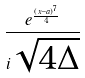Convert formula to latex. <formula><loc_0><loc_0><loc_500><loc_500>\frac { e ^ { \frac { ( x - a ) ^ { 7 } } { 4 } } } { i \sqrt { 4 \Delta } }</formula> 